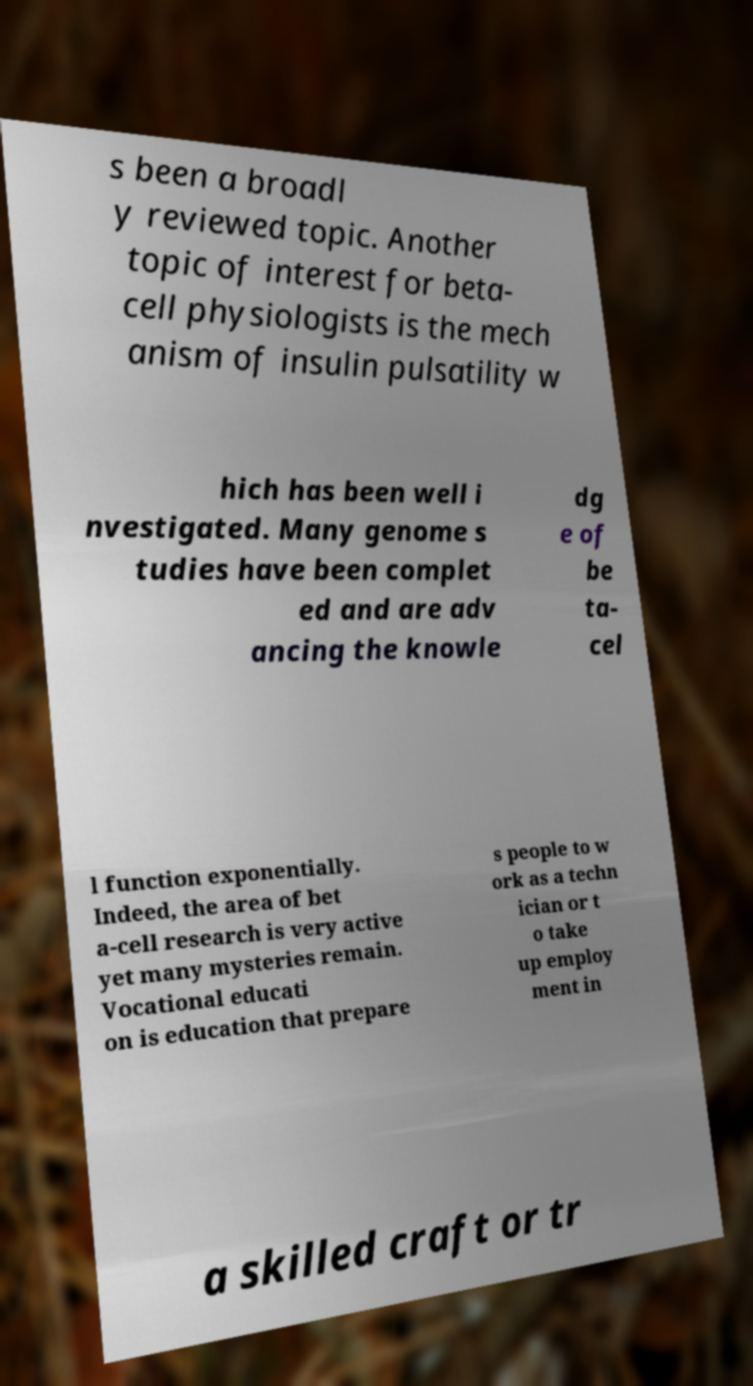Please identify and transcribe the text found in this image. s been a broadl y reviewed topic. Another topic of interest for beta- cell physiologists is the mech anism of insulin pulsatility w hich has been well i nvestigated. Many genome s tudies have been complet ed and are adv ancing the knowle dg e of be ta- cel l function exponentially. Indeed, the area of bet a-cell research is very active yet many mysteries remain. Vocational educati on is education that prepare s people to w ork as a techn ician or t o take up employ ment in a skilled craft or tr 